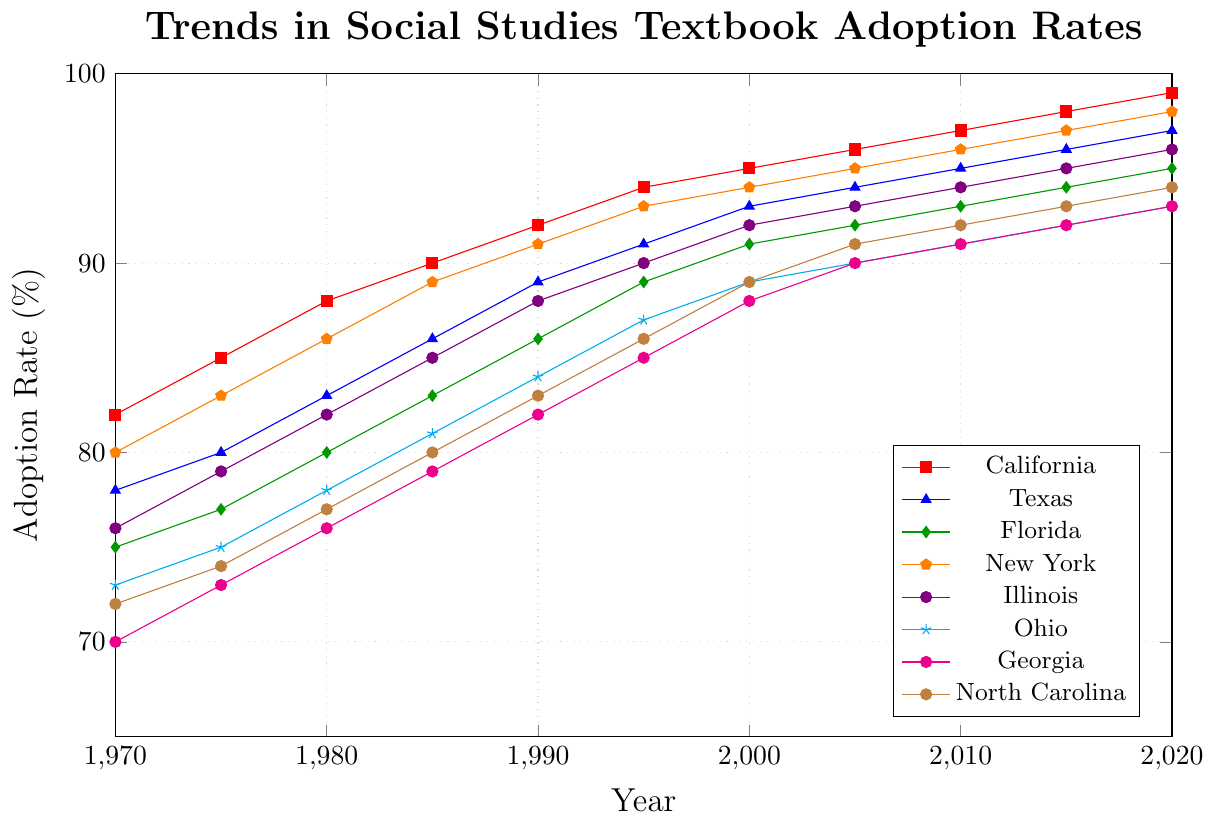What is the adoption rate for California in the year 2000? Look at the point corresponding to the year 2000 on the line representing California, which is red with a square marker. The adoption rate is 95%.
Answer: 95% Which state had the highest adoption rate in 1970? Compare the adoption rates of all states in 1970. California has the highest adoption rate of 82%.
Answer: California By how much did the adoption rate in Texas increase between 2000 and 2020? Find the adoption rates for Texas in 2000 (93%) and 2020 (97%). Calculate the difference: 97% - 93% = 4%.
Answer: 4% Which two states have the closest adoption rates in 2010? Compare the adoption rates of all states in 2010. Illinois (94%) and Georgia (91%) are the closest, with a difference of 3%.
Answer: Illinois and Georgia What is the average adoption rate for Ohio across all years? Sum the adoption rates for Ohio from all years: 73 + 75 + 78 + 81 + 84 + 87 + 89 + 90 + 91 + 92 + 93 = 933. Divide by the number of years: 933 / 11 = 84.82%.
Answer: 84.82% Which state had the smallest increase in adoption rate from 1970 to 1980? Calculate the increase for each state from 1970 to 1980. Ohio increases from 73% to 78%, which is a 5% increase. This is the smallest among all the states.
Answer: Ohio How did the adoption rate for New York change from 1995 to 2005? Find the adoption rates for New York in 1995 (93%) and 2005 (95%). The rate increased by 2%.
Answer: Increased by 2% Are there any years where Florida's adoption rate matched Ohio's exactly? Compare the adoption rates for Florida and Ohio in all years. No years have matching rates for both states.
Answer: No Between Georgia and North Carolina, which state had a higher adoption rate in 2015? Compare Georgia's adoption rate (92%) with North Carolina's (93%) for the year 2015. North Carolina has a higher rate.
Answer: North Carolina What is the trend in the adoption rate for Illinois from 1970 to 2020? Observe the line for Illinois from 1970 to 2020. The adoption rate steadily increases from 76% in 1970 to 96% in 2020.
Answer: Steadily increasing 